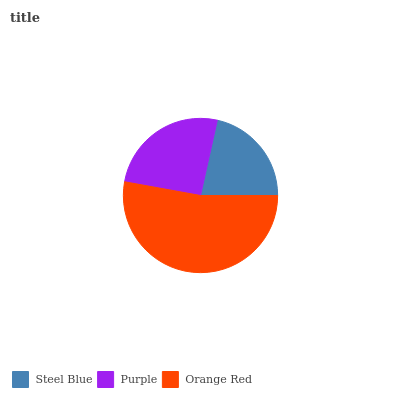Is Steel Blue the minimum?
Answer yes or no. Yes. Is Orange Red the maximum?
Answer yes or no. Yes. Is Purple the minimum?
Answer yes or no. No. Is Purple the maximum?
Answer yes or no. No. Is Purple greater than Steel Blue?
Answer yes or no. Yes. Is Steel Blue less than Purple?
Answer yes or no. Yes. Is Steel Blue greater than Purple?
Answer yes or no. No. Is Purple less than Steel Blue?
Answer yes or no. No. Is Purple the high median?
Answer yes or no. Yes. Is Purple the low median?
Answer yes or no. Yes. Is Steel Blue the high median?
Answer yes or no. No. Is Steel Blue the low median?
Answer yes or no. No. 